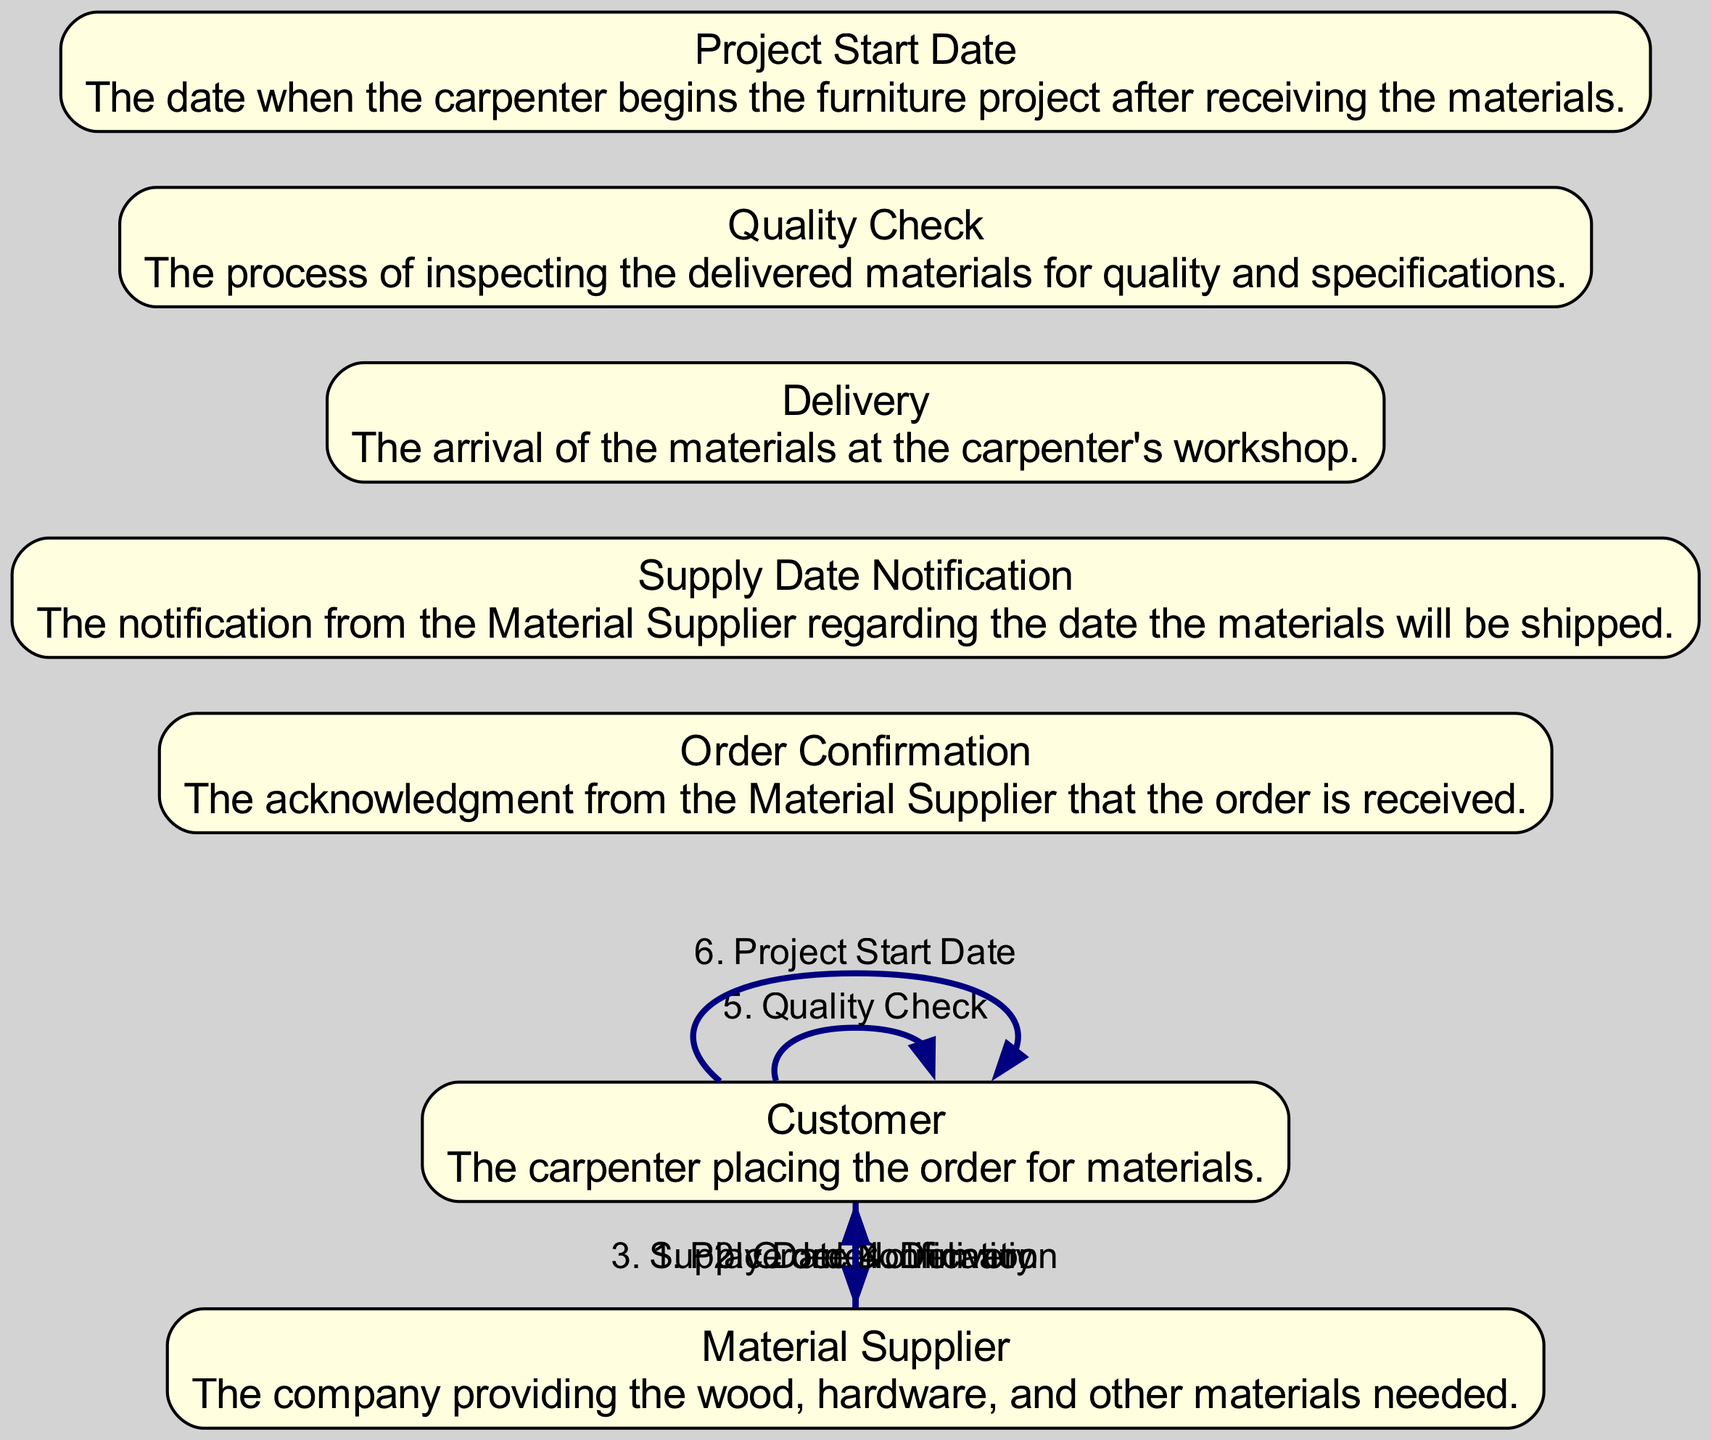What is the first action in the sequence? The diagram shows a sequence starting with the action "Place order" initiated by the Customer to the Material Supplier. This is the first step of the interaction indicating the start of the ordering process.
Answer: Place order How many nodes are present in the diagram? The diagram includes nodes for the Customer, Material Supplier, Order Confirmation, Supply Date Notification, Delivery, Quality Check, and Project Start Date. Counting these gives a total of seven nodes.
Answer: Seven What is the last action in the sequence? The final action in the sequence is "Project Start Date," which signifies when the Customer begins the furniture project after all materials have been delivered.
Answer: Project Start Date Who confirms the order with the Customer? The order confirmation is provided by the Material Supplier, indicating that the order has been successfully received and acknowledged.
Answer: Material Supplier What are the two actions that involve the Customer? The Customer is involved in the "Quality Check" process after receiving the materials and also determines the "Project Start Date" after everything is checked and ready.
Answer: Quality Check and Project Start Date Which element notifies the Customer of the delivery? The diagram shows that the delivery notification is provided by the Material Supplier, which is the entity responsible for sending the materials.
Answer: Material Supplier Before which action does the Material Supplier notify the supply date? The notification of the supply date occurs before the Customer receives the delivery of materials. It is one of the steps leading to materials arriving at the workshop.
Answer: Delivery What is the relationship between "Delivery" and "Quality Check"? The "Quality Check" is performed by the Customer after the "Delivery," meaning the Customer inspects the materials received to ensure they meet quality standards before starting the project.
Answer: After What action follows the "Order Confirmation"? The next action following the "Order Confirmation" by the Material Supplier is the "Supply Date Notification," which informs the Customer when to expect the materials to be shipped.
Answer: Supply Date Notification 